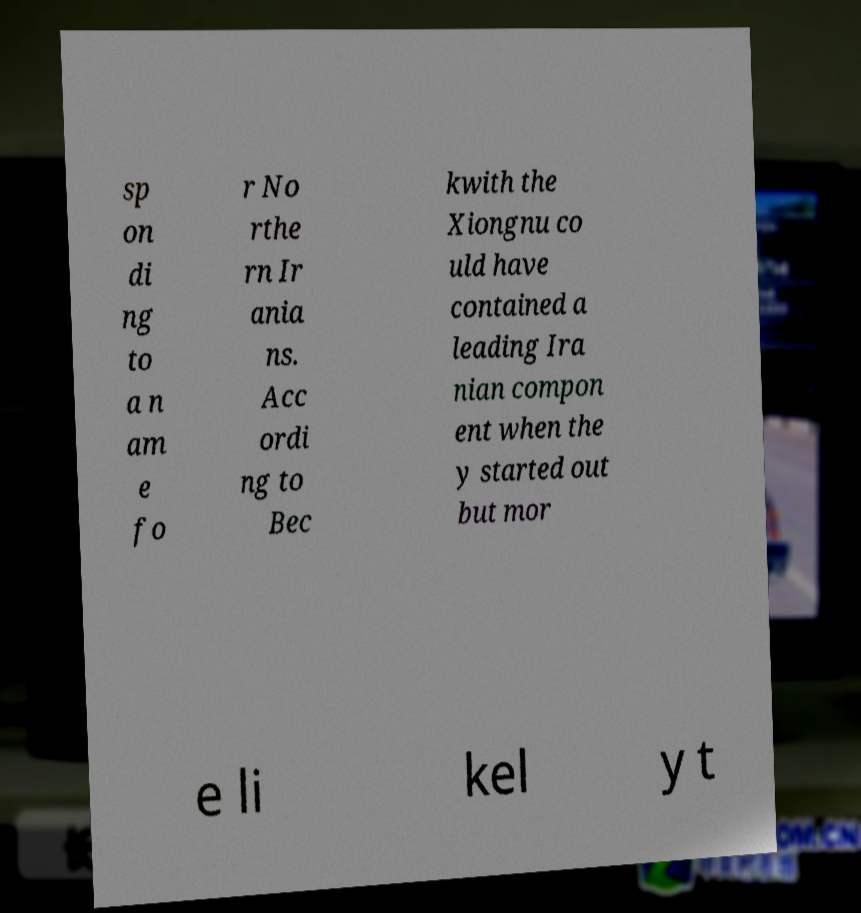Can you accurately transcribe the text from the provided image for me? sp on di ng to a n am e fo r No rthe rn Ir ania ns. Acc ordi ng to Bec kwith the Xiongnu co uld have contained a leading Ira nian compon ent when the y started out but mor e li kel y t 